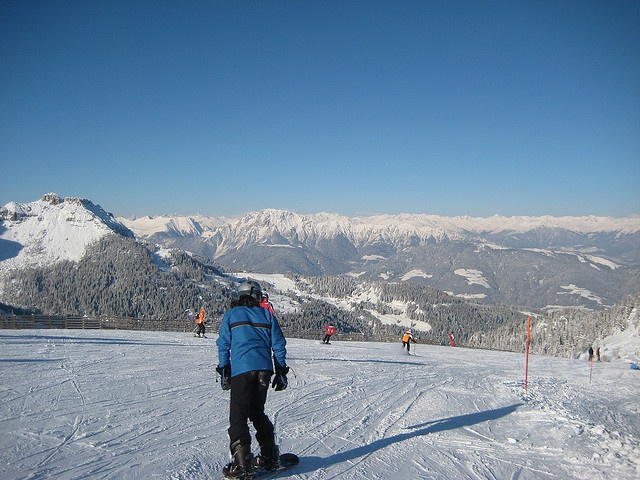Describe the objects in this image and their specific colors. I can see people in darkblue, black, blue, and navy tones, snowboard in darkblue, black, blue, and gray tones, people in darkblue, black, gray, darkgray, and red tones, people in darkblue, black, gray, darkgray, and lightgray tones, and people in darkblue, black, gray, darkgray, and red tones in this image. 